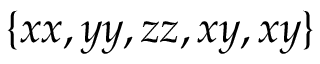Convert formula to latex. <formula><loc_0><loc_0><loc_500><loc_500>\{ x x , y y , z z , x y , x y \}</formula> 